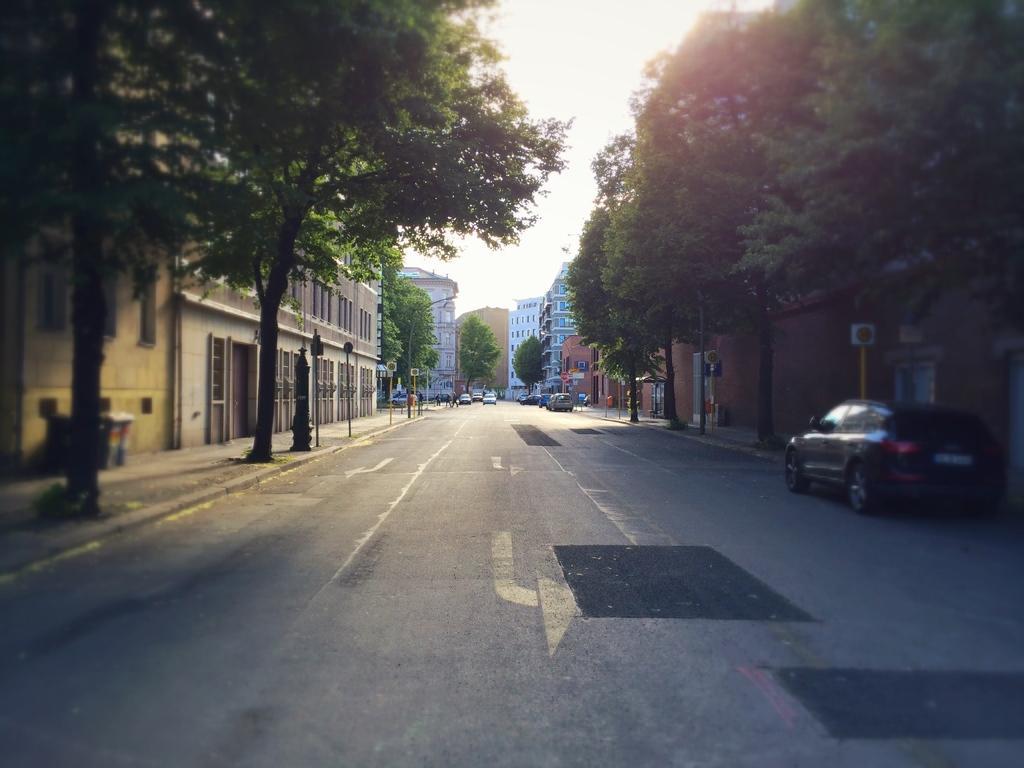Could you give a brief overview of what you see in this image? In the center of the image there are cars on the road. There are boards. On the right side of the image there is a wall. In the background of the image there are trees, buildings and sky. On the left side of the image there are dustbins. 